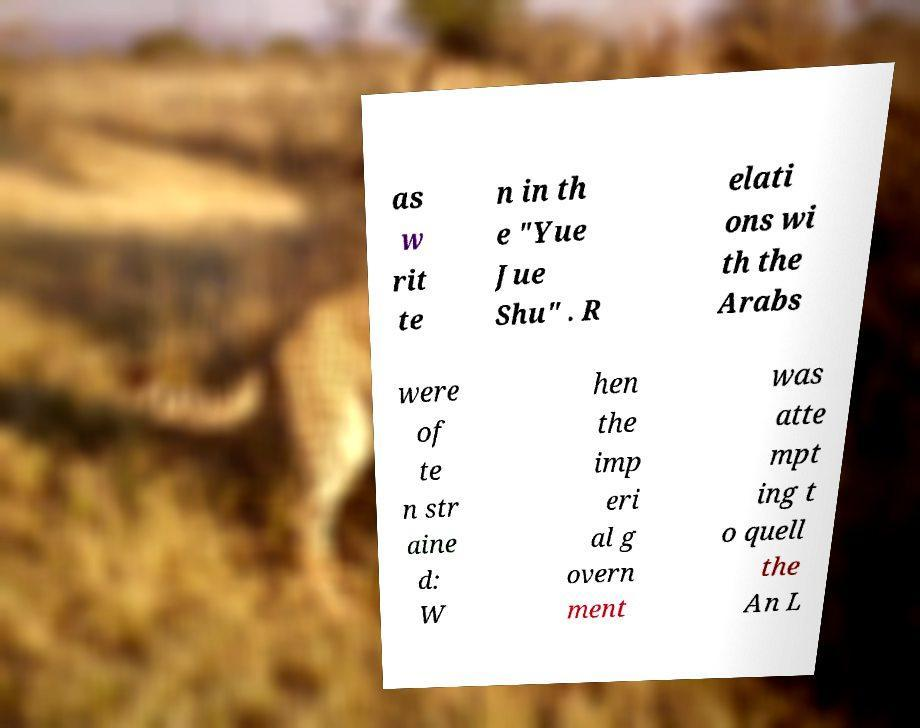What messages or text are displayed in this image? I need them in a readable, typed format. as w rit te n in th e "Yue Jue Shu" . R elati ons wi th the Arabs were of te n str aine d: W hen the imp eri al g overn ment was atte mpt ing t o quell the An L 